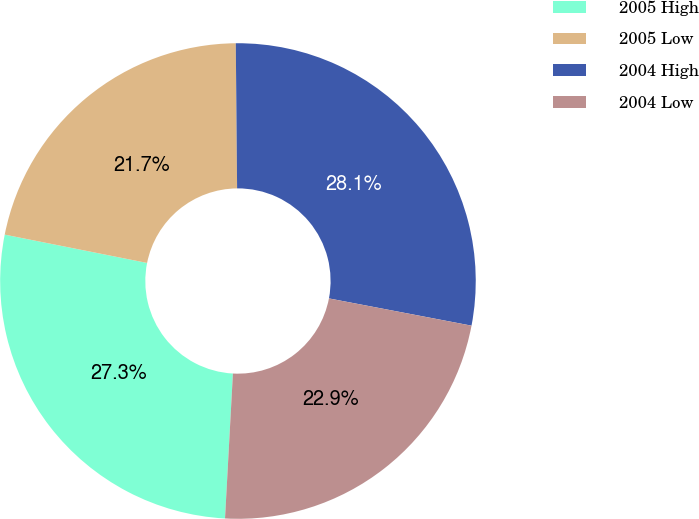<chart> <loc_0><loc_0><loc_500><loc_500><pie_chart><fcel>2005 High<fcel>2005 Low<fcel>2004 High<fcel>2004 Low<nl><fcel>27.26%<fcel>21.73%<fcel>28.15%<fcel>22.86%<nl></chart> 